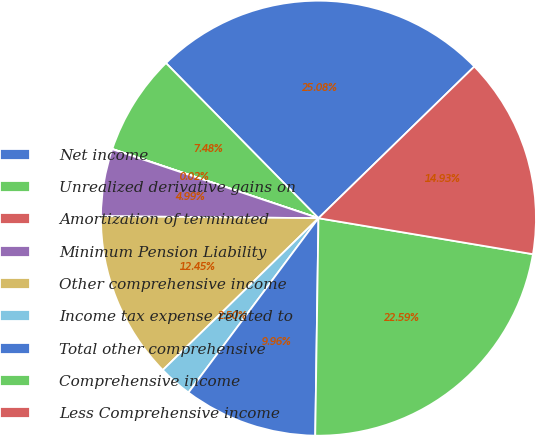Convert chart to OTSL. <chart><loc_0><loc_0><loc_500><loc_500><pie_chart><fcel>Net income<fcel>Unrealized derivative gains on<fcel>Amortization of terminated<fcel>Minimum Pension Liability<fcel>Other comprehensive income<fcel>Income tax expense related to<fcel>Total other comprehensive<fcel>Comprehensive income<fcel>Less Comprehensive income<nl><fcel>25.08%<fcel>7.48%<fcel>0.02%<fcel>4.99%<fcel>12.45%<fcel>2.5%<fcel>9.96%<fcel>22.59%<fcel>14.93%<nl></chart> 